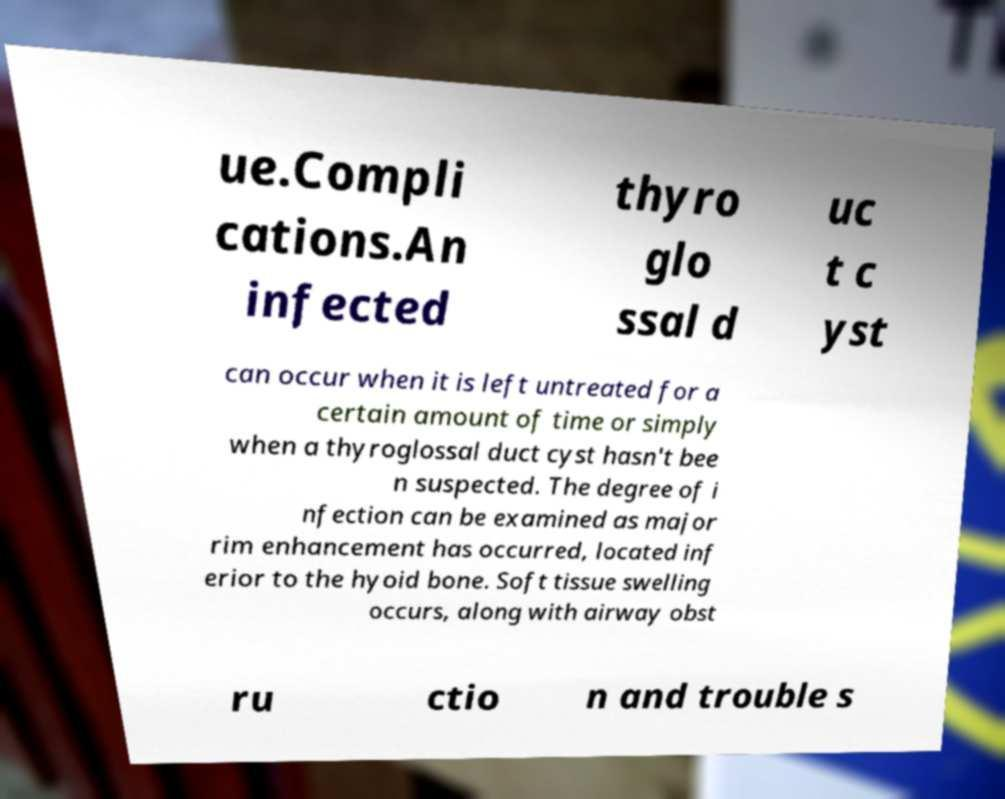Please identify and transcribe the text found in this image. ue.Compli cations.An infected thyro glo ssal d uc t c yst can occur when it is left untreated for a certain amount of time or simply when a thyroglossal duct cyst hasn't bee n suspected. The degree of i nfection can be examined as major rim enhancement has occurred, located inf erior to the hyoid bone. Soft tissue swelling occurs, along with airway obst ru ctio n and trouble s 